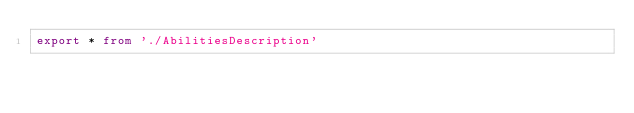Convert code to text. <code><loc_0><loc_0><loc_500><loc_500><_TypeScript_>export * from './AbilitiesDescription'
</code> 